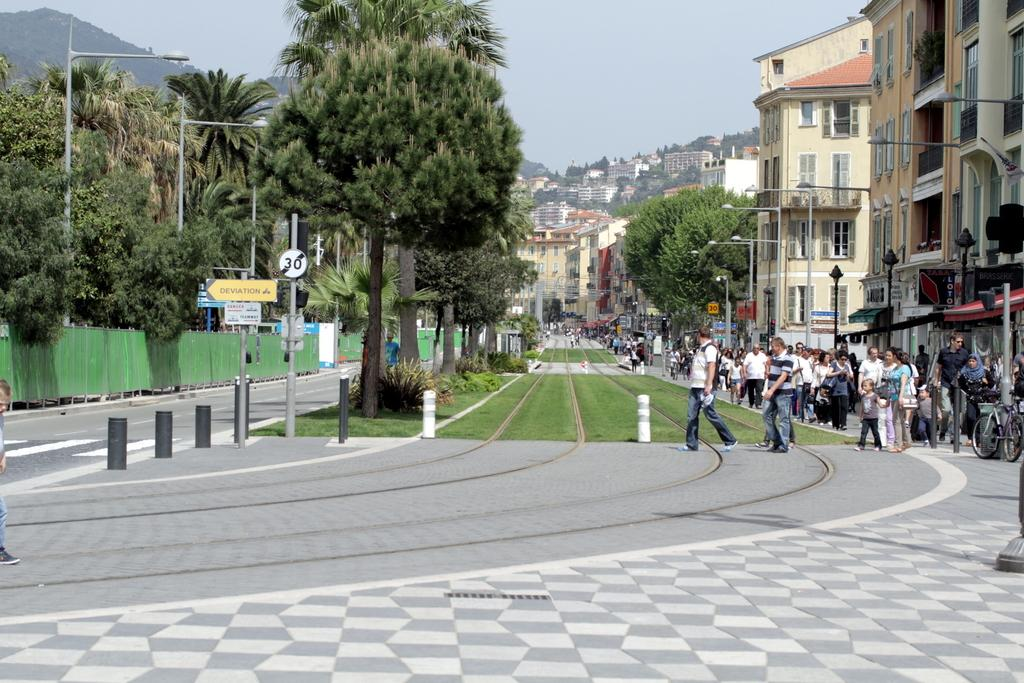What type of vegetation can be seen in the image? There is grass and trees in the image. What type of structures are present in the image? There are buildings in the image. What type of lighting is present in the image? There are street lamps in the image. Who or what is present in the image? There are people and a bicycle in the image. What else can be seen in the image besides the vegetation, structures, and lighting? There are plants in the image. What is visible in the background of the image? The sky is visible in the image. What type of property is being sold in the image? There is no indication of any property being sold in the image. What type of army is present in the image? There is no army present in the image. 